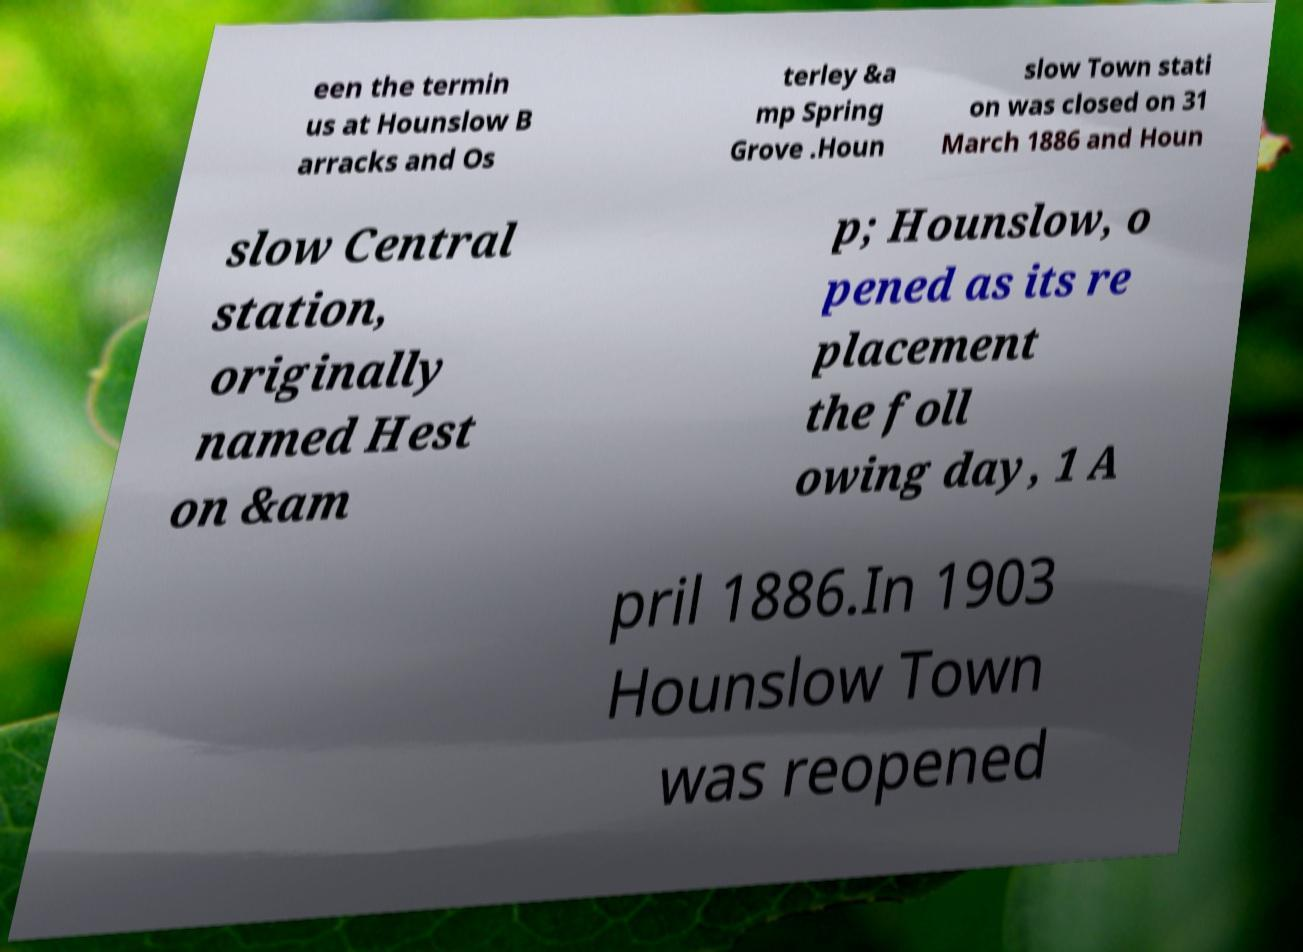What messages or text are displayed in this image? I need them in a readable, typed format. een the termin us at Hounslow B arracks and Os terley &a mp Spring Grove .Houn slow Town stati on was closed on 31 March 1886 and Houn slow Central station, originally named Hest on &am p; Hounslow, o pened as its re placement the foll owing day, 1 A pril 1886.In 1903 Hounslow Town was reopened 